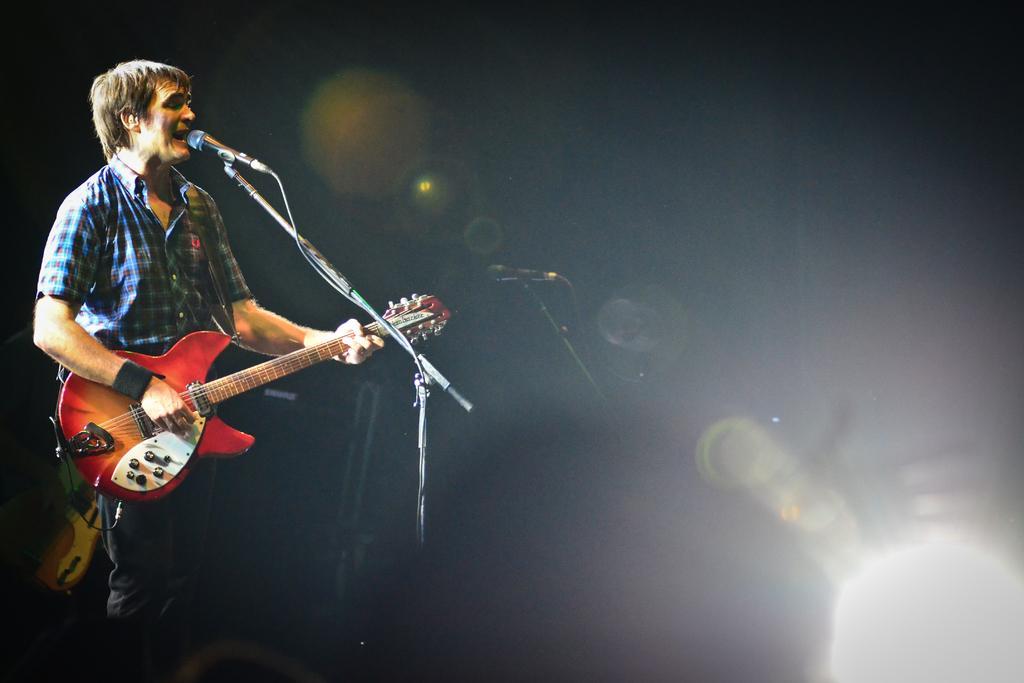Can you describe this image briefly? As we can see in the image, there is a man standing and singing on mike and holding red color guitar in his hands. 